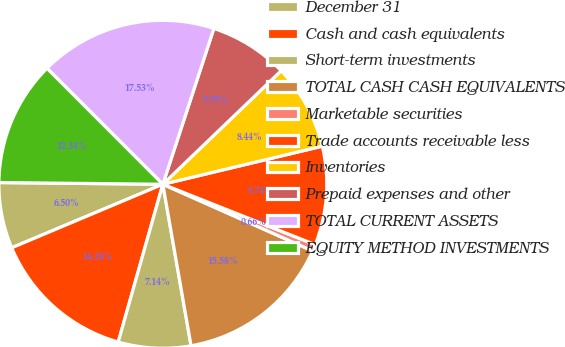Convert chart to OTSL. <chart><loc_0><loc_0><loc_500><loc_500><pie_chart><fcel>December 31<fcel>Cash and cash equivalents<fcel>Short-term investments<fcel>TOTAL CASH CASH EQUIVALENTS<fcel>Marketable securities<fcel>Trade accounts receivable less<fcel>Inventories<fcel>Prepaid expenses and other<fcel>TOTAL CURRENT ASSETS<fcel>EQUITY METHOD INVESTMENTS<nl><fcel>6.5%<fcel>14.28%<fcel>7.14%<fcel>15.58%<fcel>0.66%<fcel>9.74%<fcel>8.44%<fcel>7.79%<fcel>17.53%<fcel>12.34%<nl></chart> 